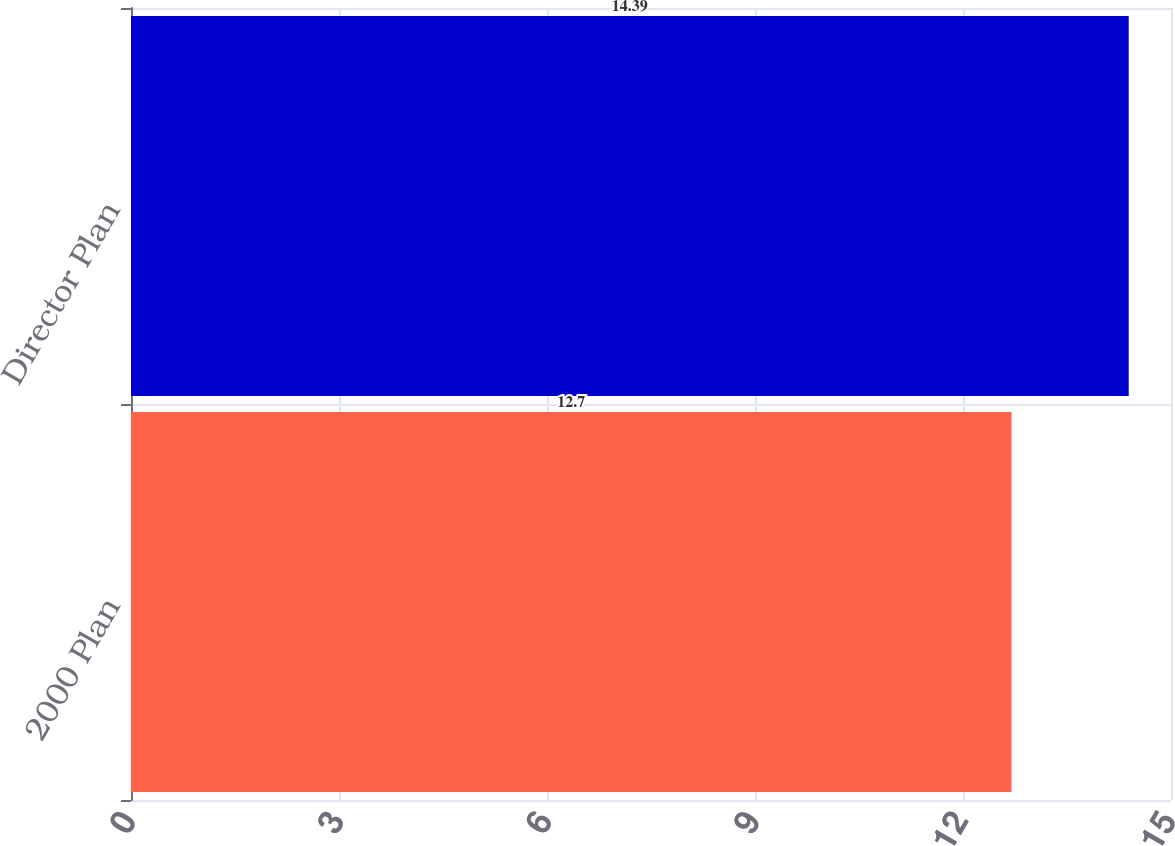Convert chart. <chart><loc_0><loc_0><loc_500><loc_500><bar_chart><fcel>2000 Plan<fcel>Director Plan<nl><fcel>12.7<fcel>14.39<nl></chart> 